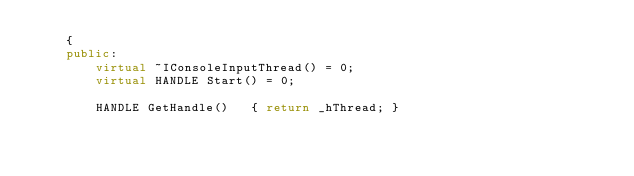<code> <loc_0><loc_0><loc_500><loc_500><_C++_>    {
    public:
        virtual ~IConsoleInputThread() = 0;
        virtual HANDLE Start() = 0;

        HANDLE GetHandle()   { return _hThread; }</code> 